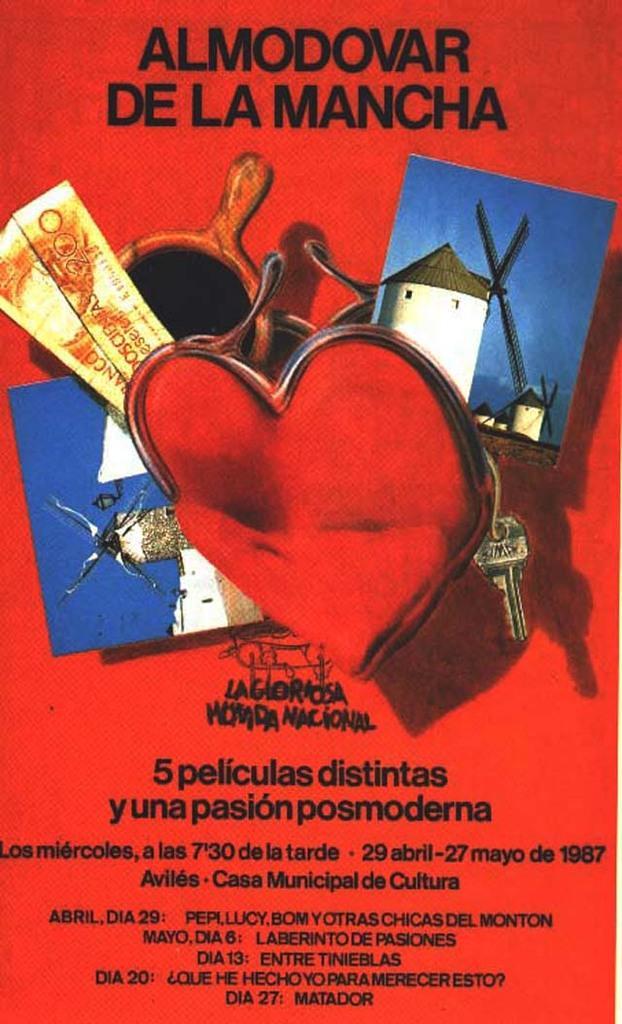Please provide a concise description of this image. In this image I can see it looks like a book´s outer cover, in this there are images. At the bottom there is the text. 